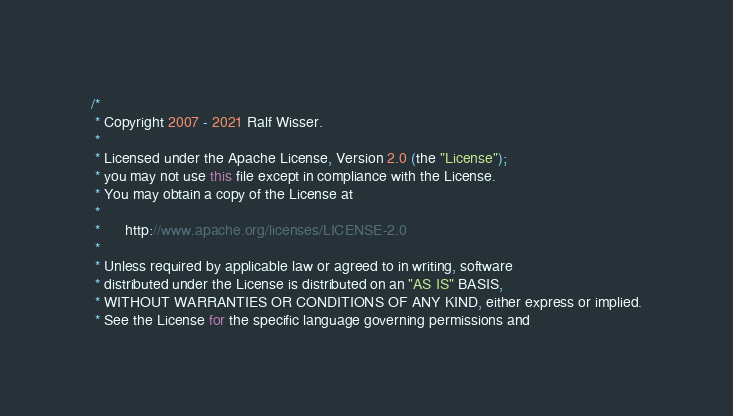<code> <loc_0><loc_0><loc_500><loc_500><_Java_>/*
 * Copyright 2007 - 2021 Ralf Wisser.
 *
 * Licensed under the Apache License, Version 2.0 (the "License");
 * you may not use this file except in compliance with the License.
 * You may obtain a copy of the License at
 *
 *      http://www.apache.org/licenses/LICENSE-2.0
 *
 * Unless required by applicable law or agreed to in writing, software
 * distributed under the License is distributed on an "AS IS" BASIS,
 * WITHOUT WARRANTIES OR CONDITIONS OF ANY KIND, either express or implied.
 * See the License for the specific language governing permissions and</code> 